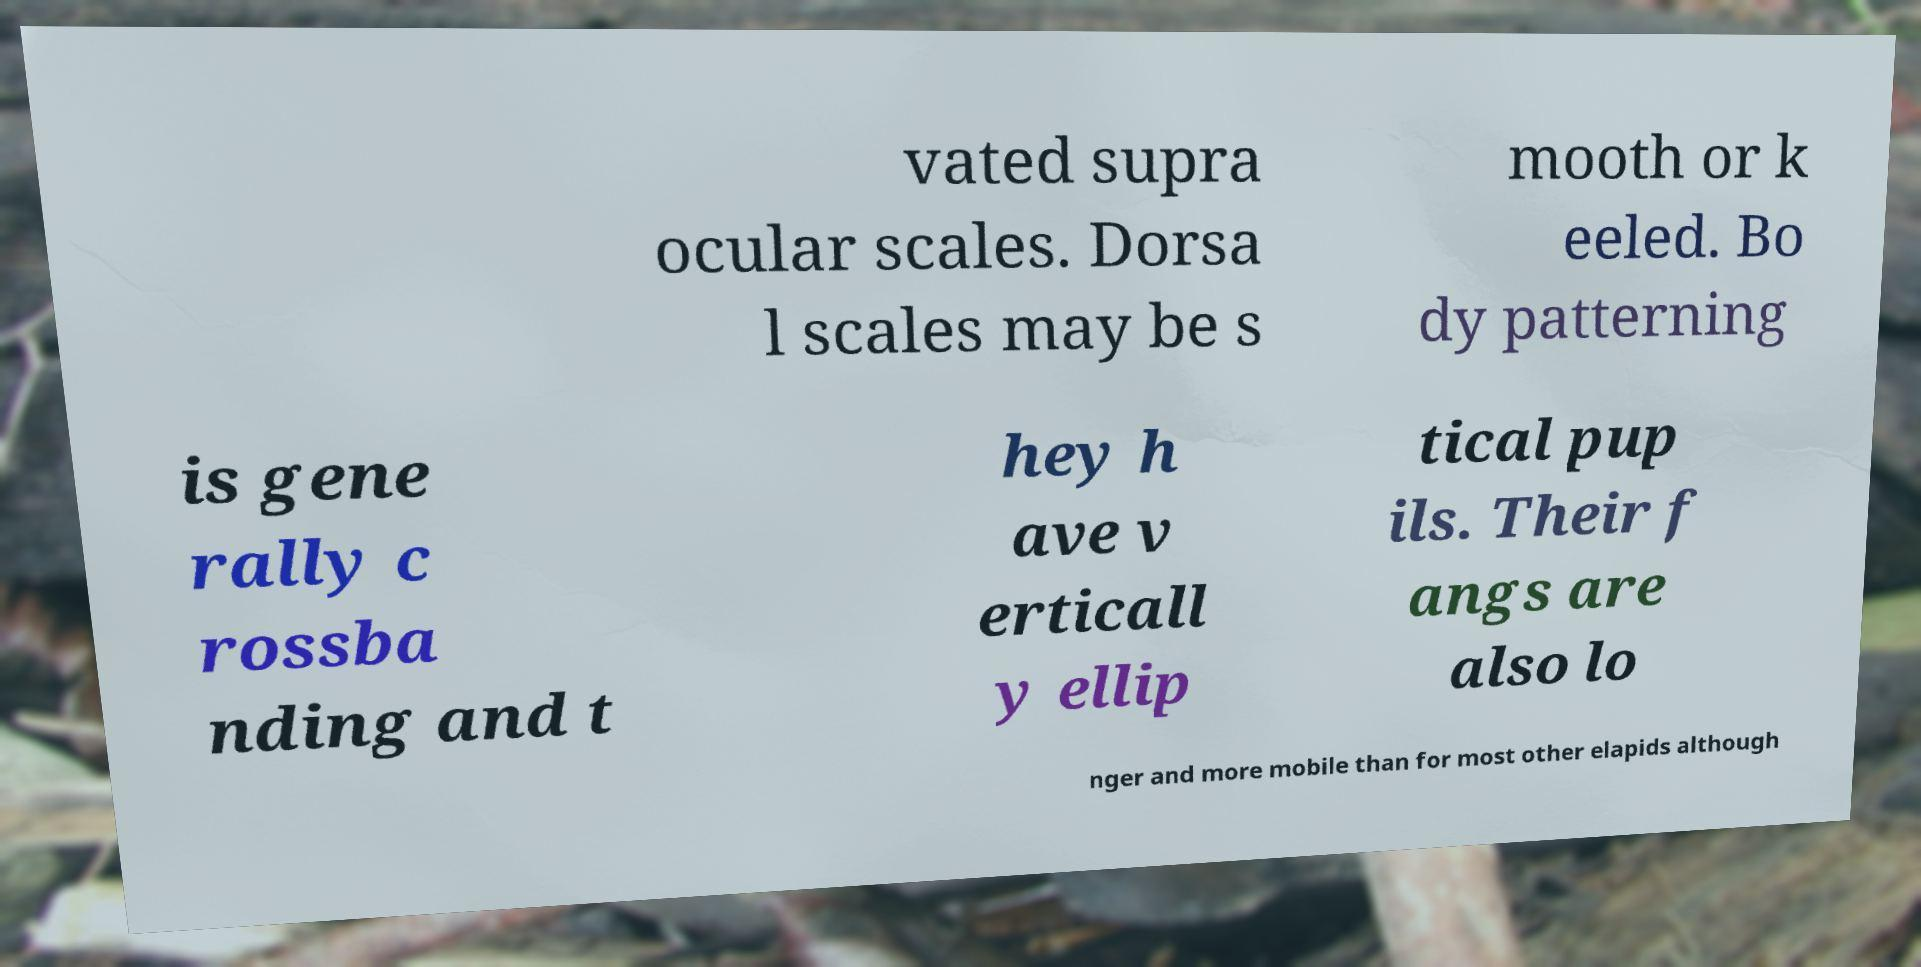Could you assist in decoding the text presented in this image and type it out clearly? vated supra ocular scales. Dorsa l scales may be s mooth or k eeled. Bo dy patterning is gene rally c rossba nding and t hey h ave v erticall y ellip tical pup ils. Their f angs are also lo nger and more mobile than for most other elapids although 